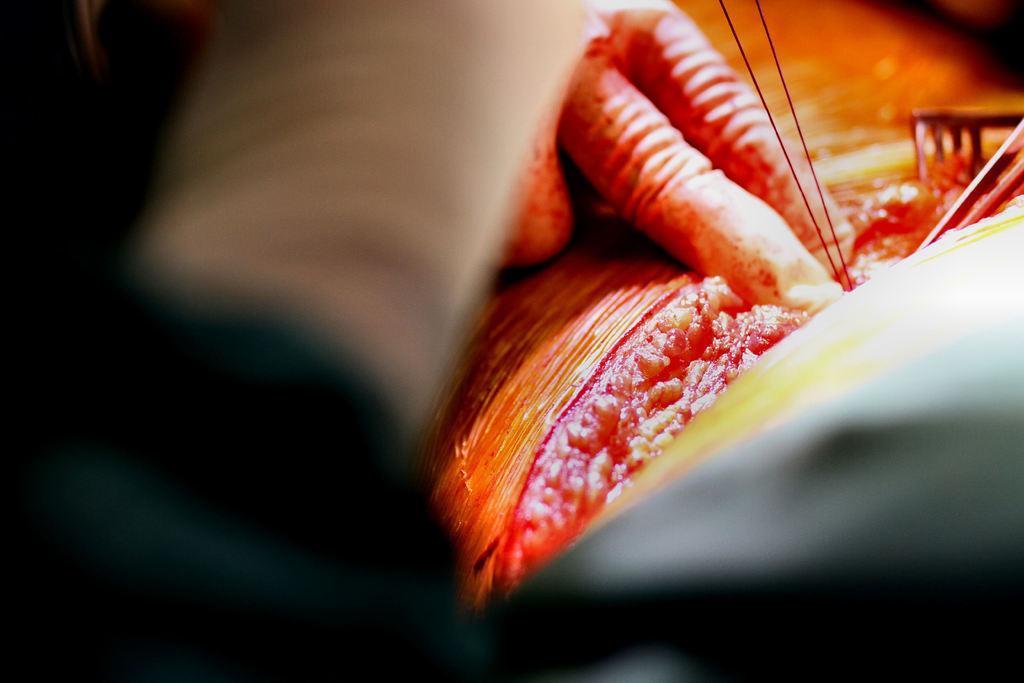Describe this image in one or two sentences. In this picture we can see a person's fingers, threads and some objects. 